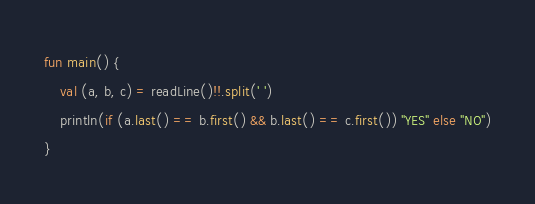<code> <loc_0><loc_0><loc_500><loc_500><_Kotlin_>fun main() {
    val (a, b, c) = readLine()!!.split(' ')
    println(if (a.last() == b.first() && b.last() == c.first()) "YES" else "NO")
}</code> 